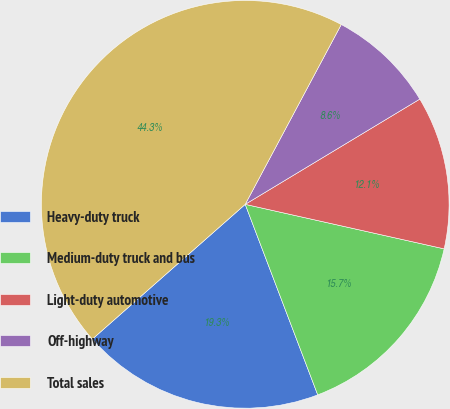Convert chart. <chart><loc_0><loc_0><loc_500><loc_500><pie_chart><fcel>Heavy-duty truck<fcel>Medium-duty truck and bus<fcel>Light-duty automotive<fcel>Off-highway<fcel>Total sales<nl><fcel>19.29%<fcel>15.71%<fcel>12.14%<fcel>8.56%<fcel>44.31%<nl></chart> 